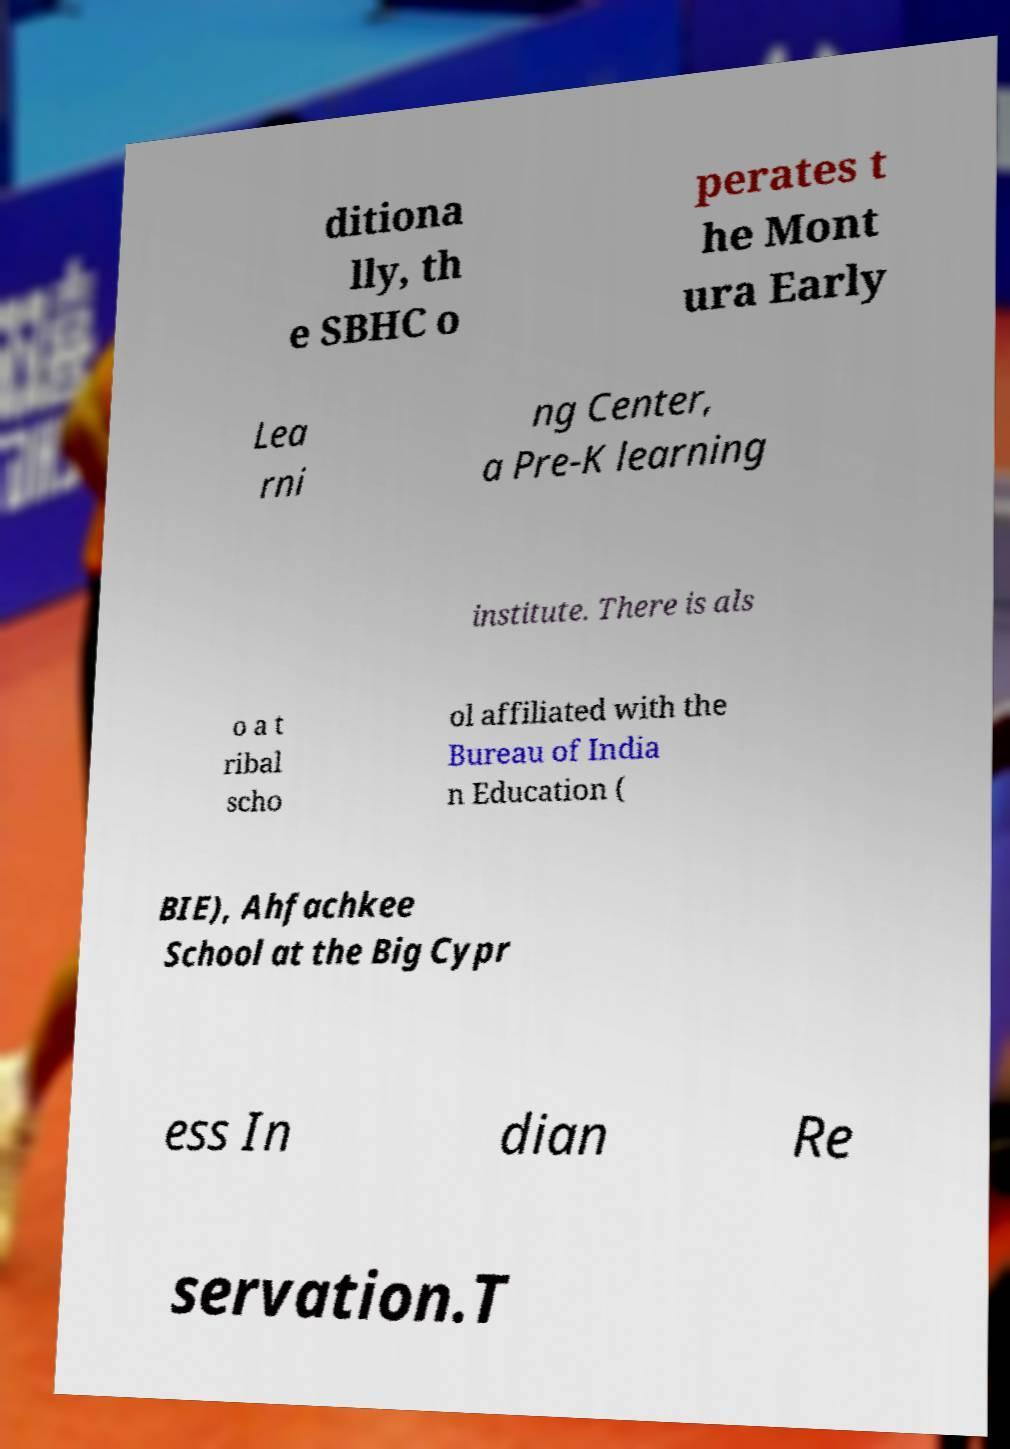Could you extract and type out the text from this image? ditiona lly, th e SBHC o perates t he Mont ura Early Lea rni ng Center, a Pre-K learning institute. There is als o a t ribal scho ol affiliated with the Bureau of India n Education ( BIE), Ahfachkee School at the Big Cypr ess In dian Re servation.T 